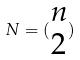Convert formula to latex. <formula><loc_0><loc_0><loc_500><loc_500>N = ( \begin{matrix} n \\ 2 \end{matrix} )</formula> 